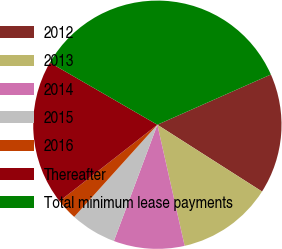Convert chart. <chart><loc_0><loc_0><loc_500><loc_500><pie_chart><fcel>2012<fcel>2013<fcel>2014<fcel>2015<fcel>2016<fcel>Thereafter<fcel>Total minimum lease payments<nl><fcel>15.67%<fcel>12.44%<fcel>9.22%<fcel>5.99%<fcel>2.76%<fcel>18.9%<fcel>35.03%<nl></chart> 